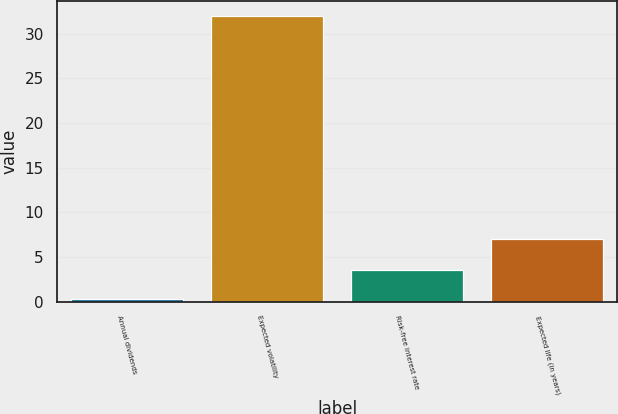Convert chart to OTSL. <chart><loc_0><loc_0><loc_500><loc_500><bar_chart><fcel>Annual dividends<fcel>Expected volatility<fcel>Risk-free interest rate<fcel>Expected life (in years)<nl><fcel>0.3<fcel>32<fcel>3.5<fcel>7<nl></chart> 